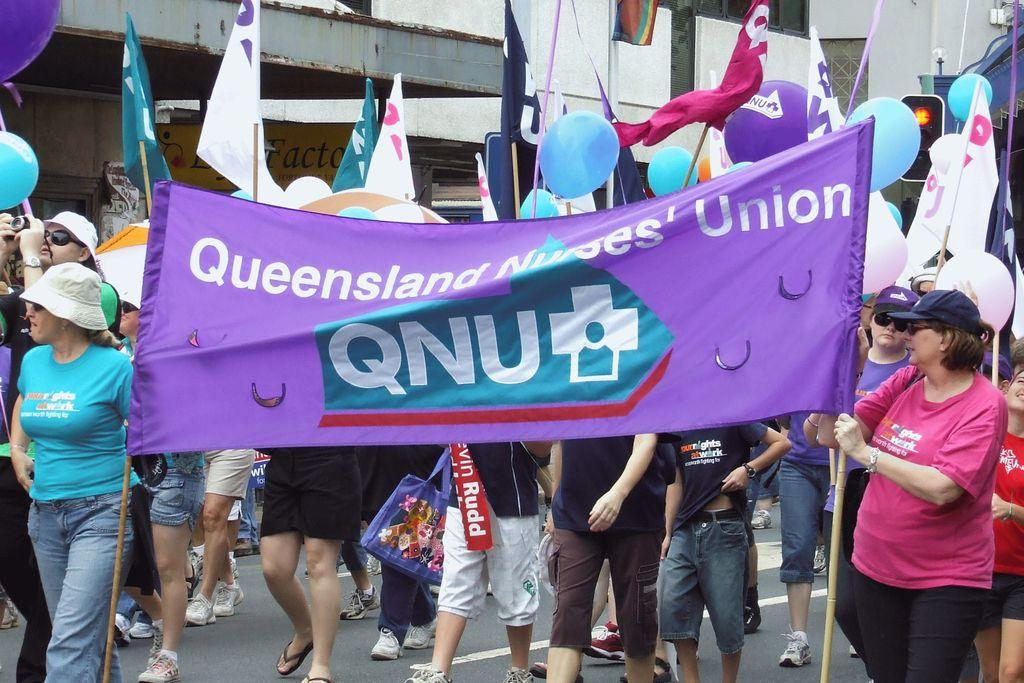How many people are in the image? There are many persons in the image. What can be seen in the front of the image? There is a banner, flags, and balloons in the front of the image. What is at the bottom of the image? There is a road at the bottom of the image. What is visible in the background of the image? There are buildings in the background of the image. Reasoning: Let' Let's think step by step in order to produce the conversation. We start by identifying the main subject in the image, which is the many persons. Then, we expand the conversation to include other items that are also visible, such as the banner, flags, balloons, road, and buildings. Each question is designed to elicit a specific detail about the image that is known from the provided facts. Absurd Question/Answer: What type of linen is being used to make the flags in the image? There is no information about the type of linen used for the flags in the image. Can you tell me the name of the father of one of the persons in the image? There is no information about the names or relationships of the persons in the image. 